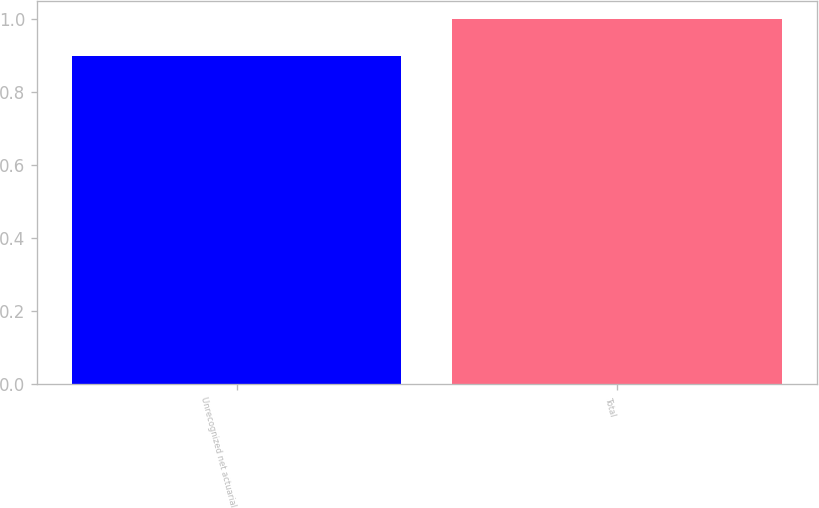Convert chart to OTSL. <chart><loc_0><loc_0><loc_500><loc_500><bar_chart><fcel>Unrecognized net actuarial<fcel>Total<nl><fcel>0.9<fcel>1<nl></chart> 